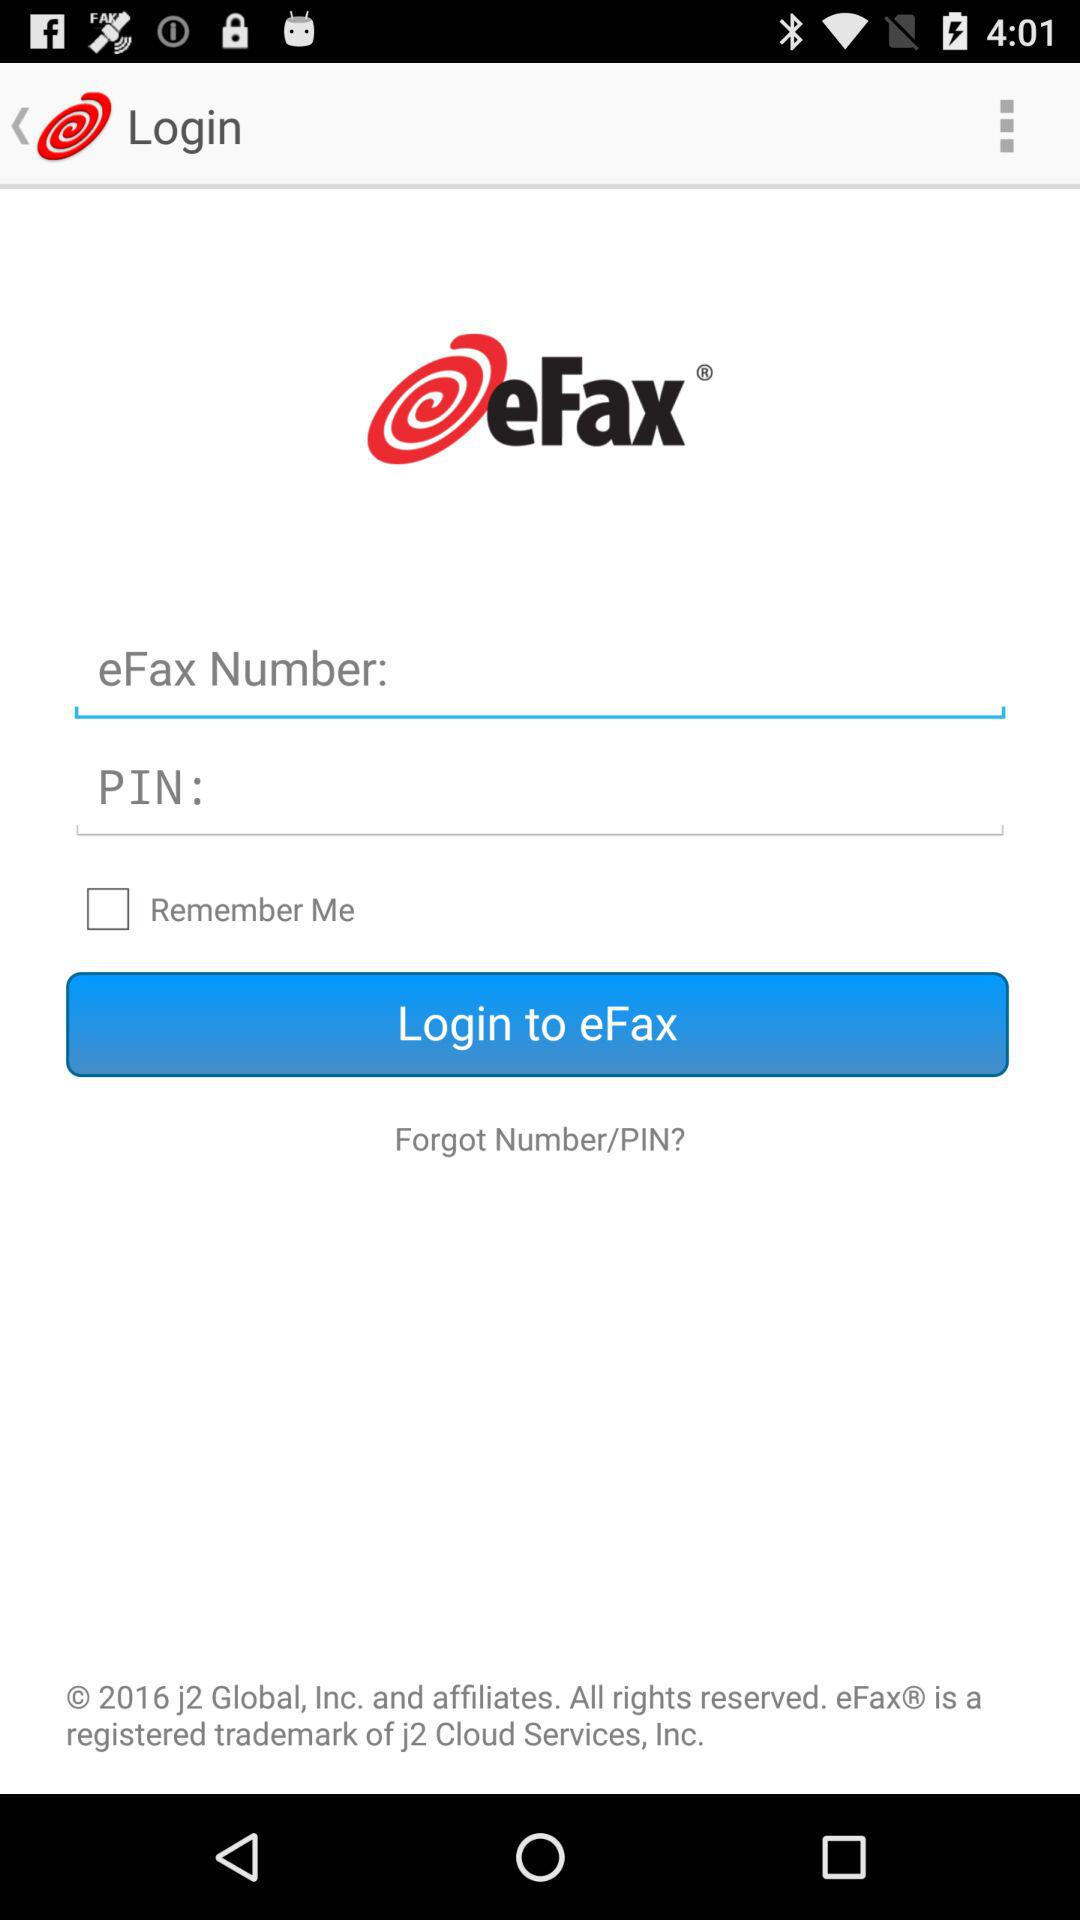What is the application name? The application name is "eFax Fax App - Fax by Phone". 